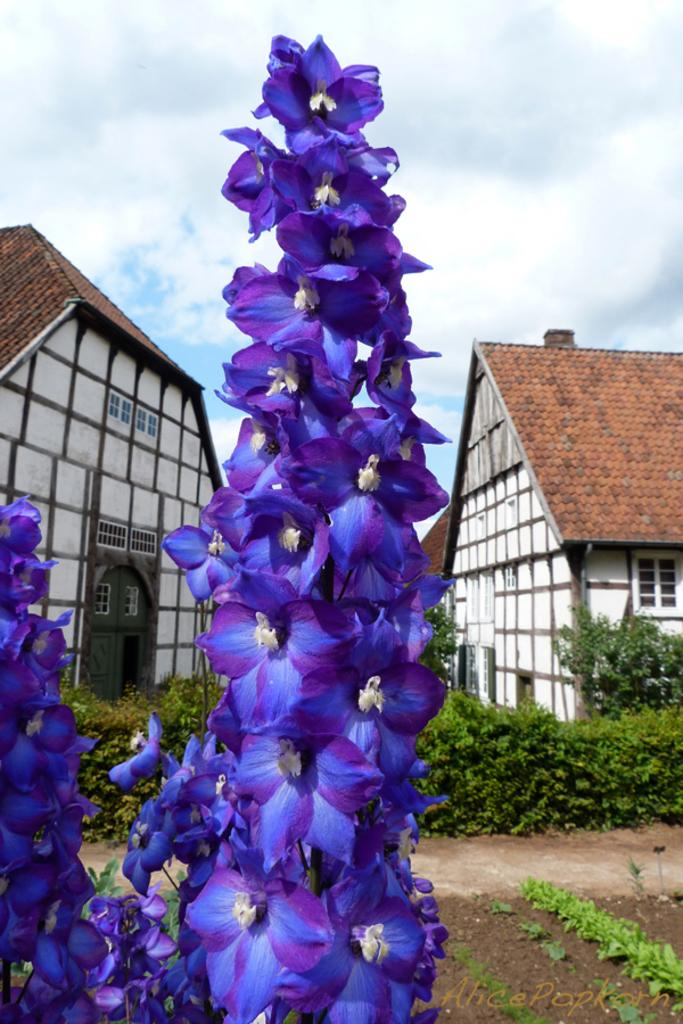What type of flora can be seen in the image? There are flowers in the image. What colors are the flowers? The flowers are purple and blue in color. What type of structures are present in the image? There are buildings in the image. What other types of vegetation can be seen in the image? There are plants and grass in the image. How would you describe the weather in the image? The sky is cloudy in the image. Can you tell me how many geese are present in the image? There are no geese present in the image. What type of yarn is being used to create the flowers in the image? The flowers in the image are real, and there is no yarn involved in their creation. 